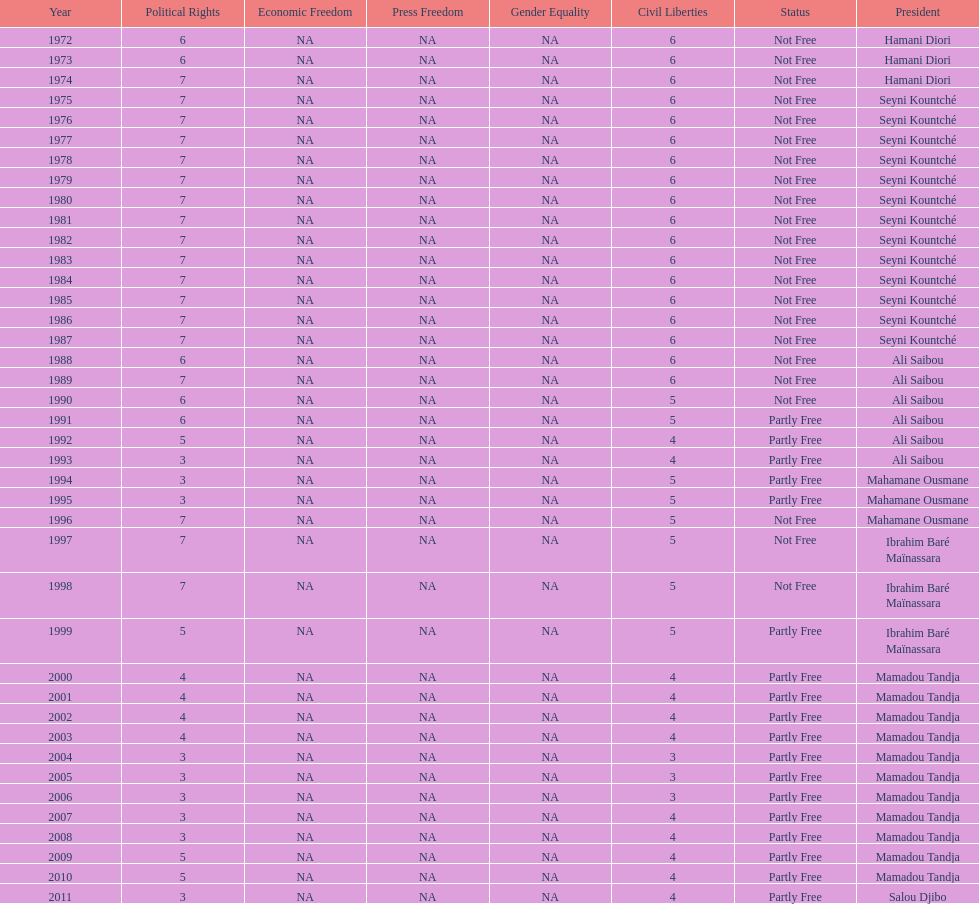What is the number of time seyni kountche has been president? 13. 